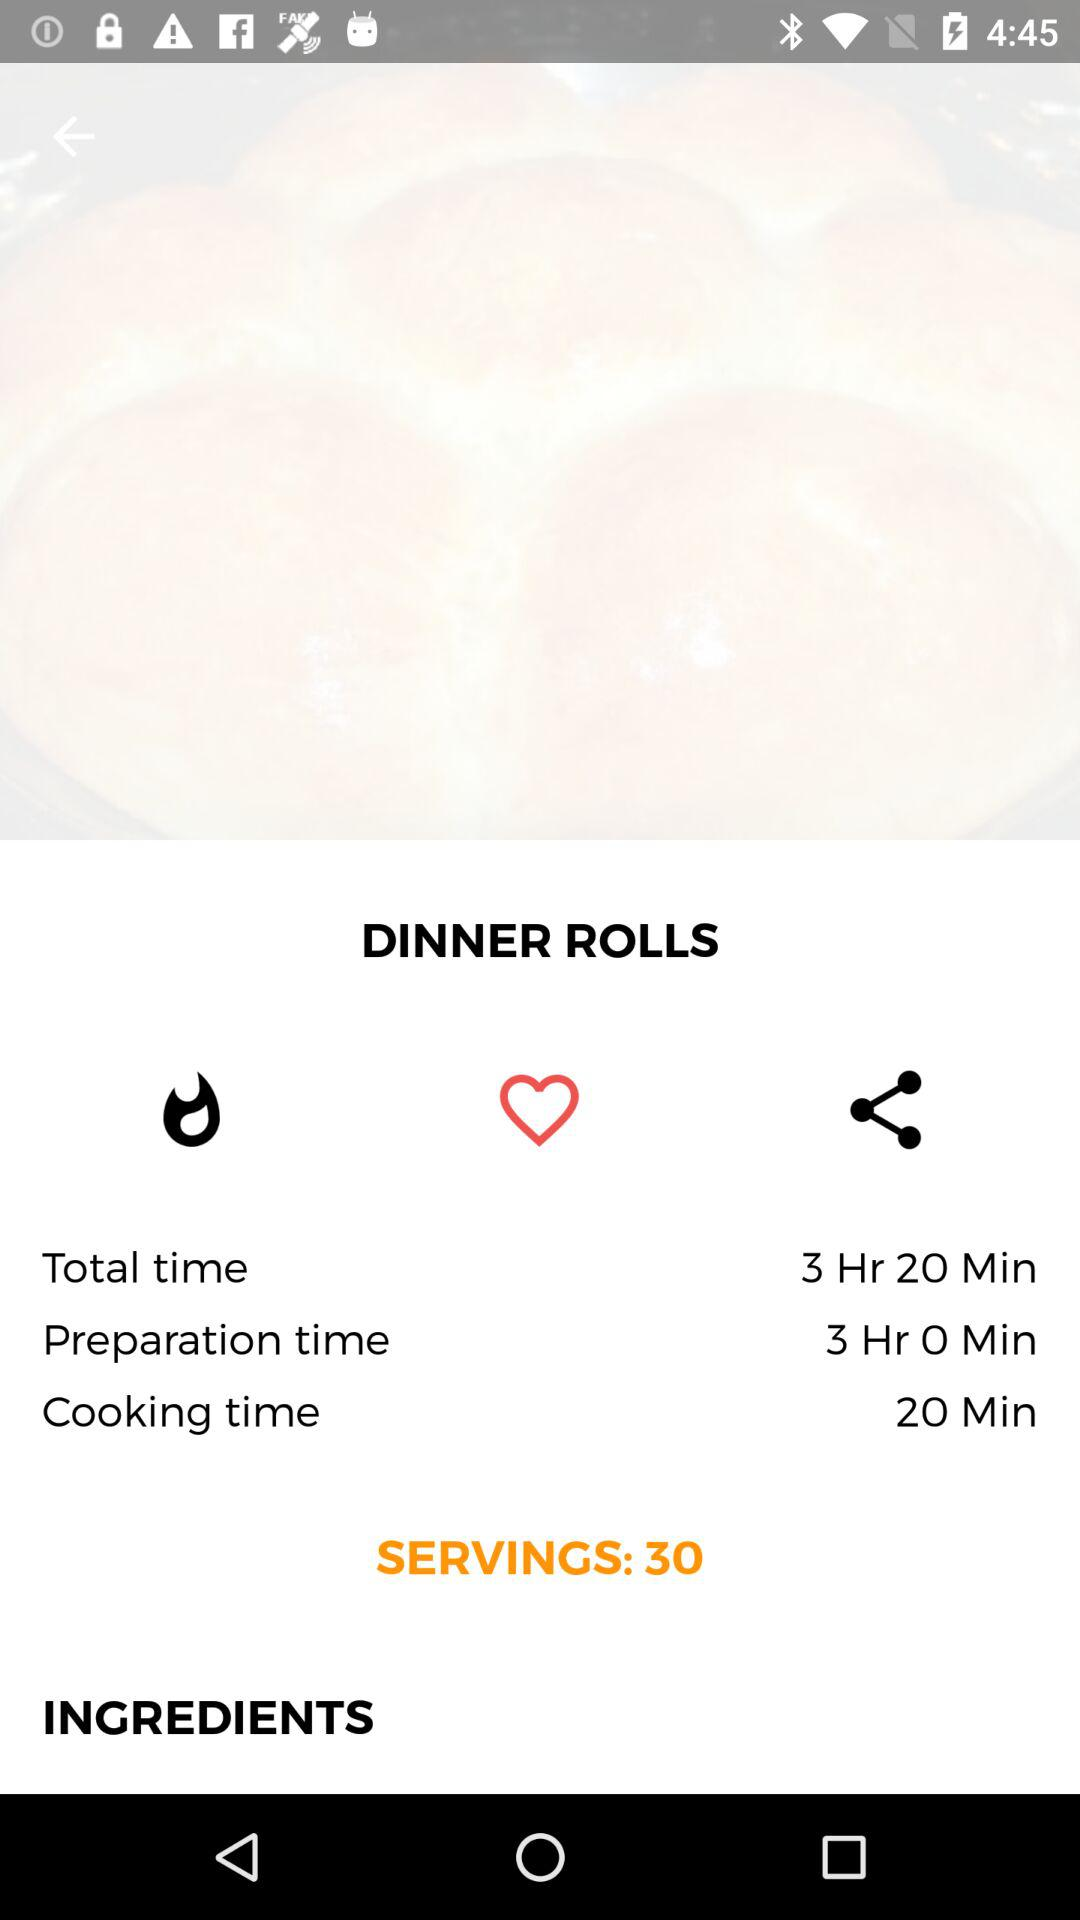How many people can be served? There can be 30 people served. 